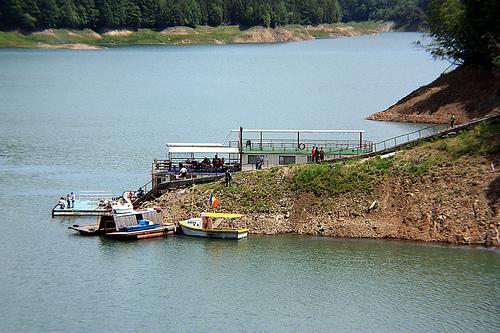Is this a city?
Answer briefly. No. What flag is flown at the end of the boat?
Write a very short answer. France. Are there any people at the dock?
Be succinct. Yes. Is this a busy dock?
Concise answer only. No. Which boat is motorized?
Be succinct. Right. Where is this?
Write a very short answer. Lake. Is there an up ramp?
Quick response, please. Yes. How many boats are there?
Give a very brief answer. 2. 